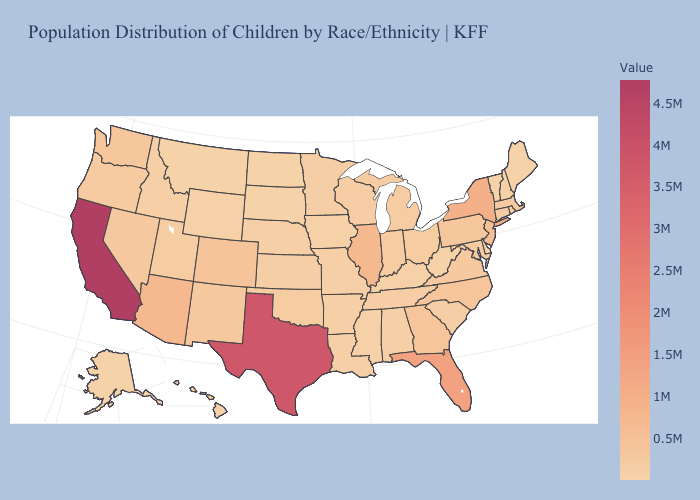Which states have the lowest value in the USA?
Short answer required. Vermont. Does Kansas have the highest value in the MidWest?
Be succinct. No. Does California have the highest value in the USA?
Quick response, please. Yes. Does Illinois have the highest value in the MidWest?
Short answer required. Yes. Among the states that border Iowa , does Minnesota have the highest value?
Keep it brief. No. Which states have the highest value in the USA?
Quick response, please. California. Among the states that border Kansas , does Nebraska have the highest value?
Concise answer only. No. 